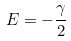<formula> <loc_0><loc_0><loc_500><loc_500>E = - \frac { \gamma } { 2 }</formula> 